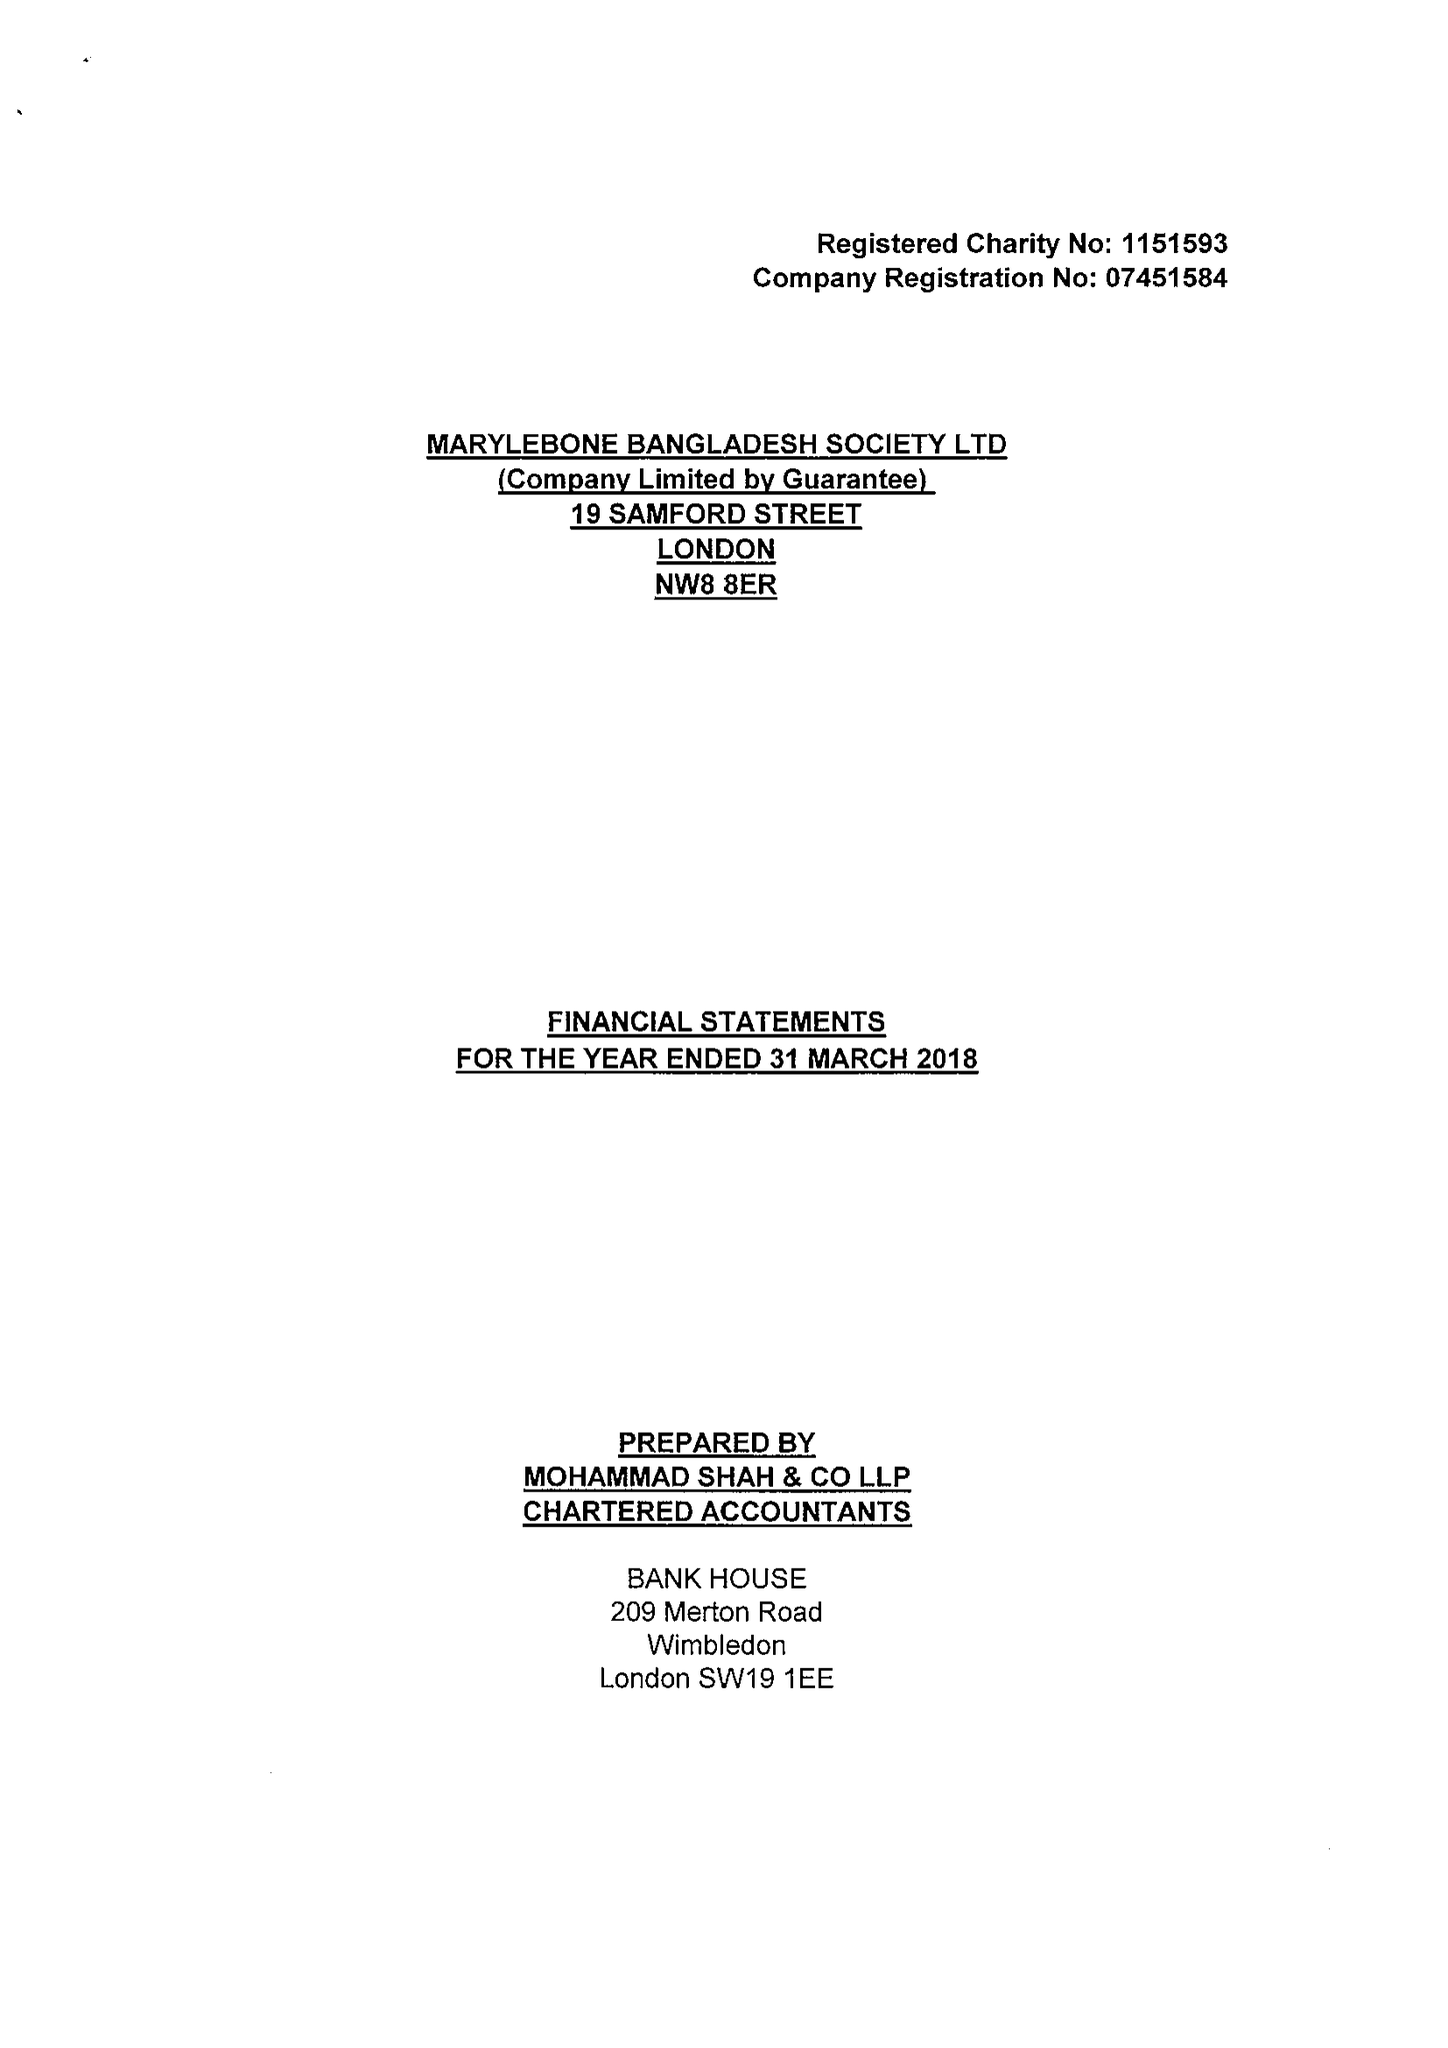What is the value for the charity_number?
Answer the question using a single word or phrase. 1151593 